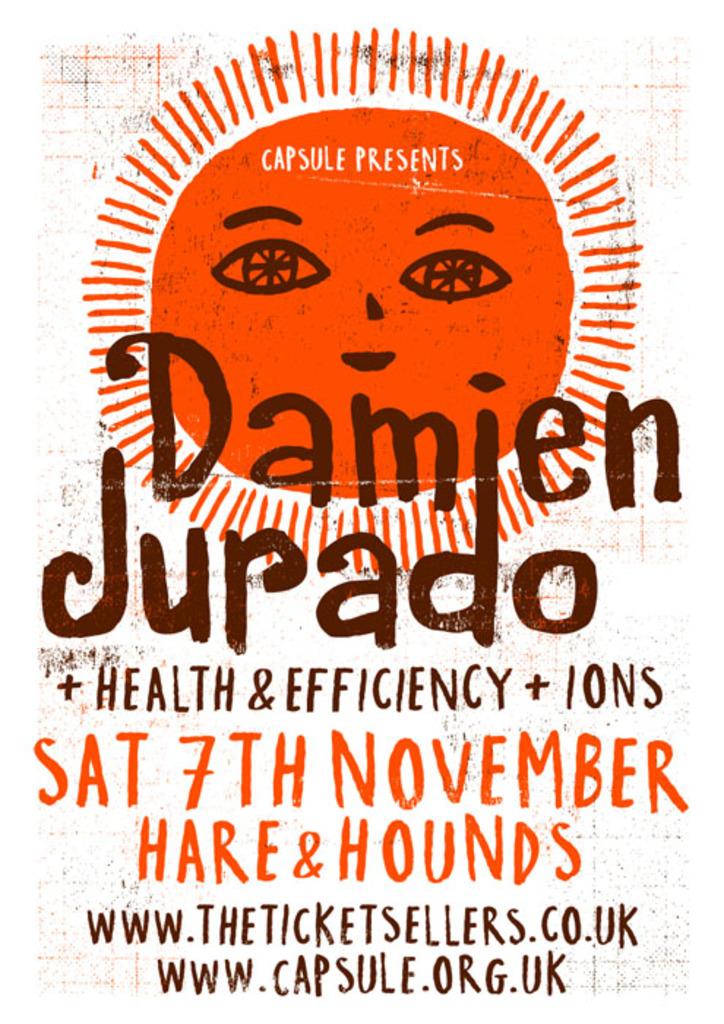What is the url at the bottom?
Make the answer very short. Www.capsule.org.uk. 